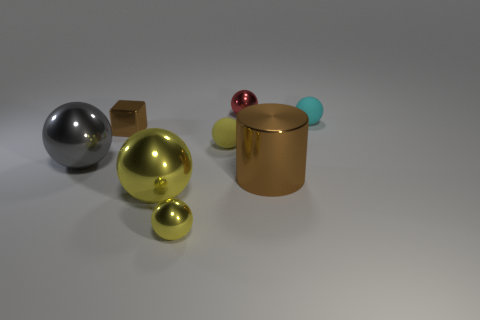Subtract all tiny balls. How many balls are left? 2 Subtract all yellow balls. How many balls are left? 3 Add 1 tiny shiny cubes. How many objects exist? 9 Subtract all balls. How many objects are left? 2 Subtract 2 balls. How many balls are left? 4 Subtract all brown blocks. How many red cylinders are left? 0 Subtract all brown blocks. Subtract all small brown metal blocks. How many objects are left? 6 Add 2 matte objects. How many matte objects are left? 4 Add 8 tiny rubber things. How many tiny rubber things exist? 10 Subtract 0 green cylinders. How many objects are left? 8 